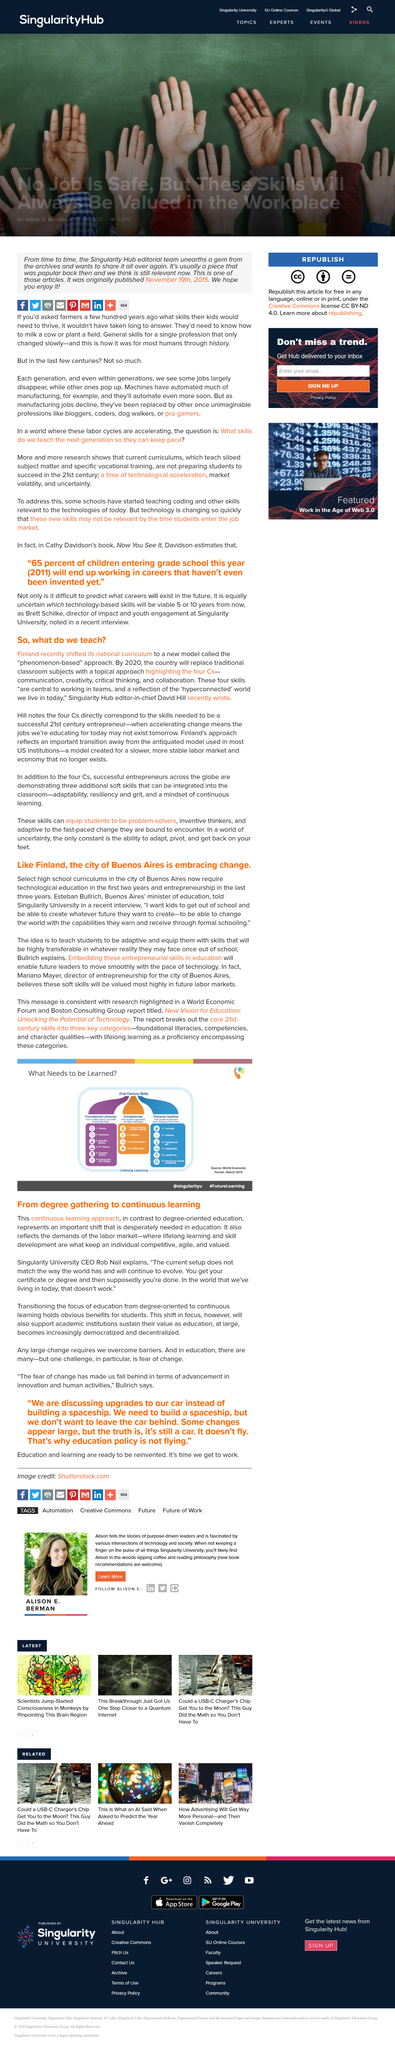Highlight a few significant elements in this photo. Yes, communication, creativity, critical thinking, and collaboration are skills that are essential for success as an entrepreneur in the 21st century. The select high schools in Buenos Aires require two years of technological education. David Hill is the editor-in-chief for Singularity Hub. The report from the World Economic Forum and Boston Consulting Group, titled "New Vision for Education: Unlocking the Potential of Technology", provides a comprehensive overview of the potential of technology in education and outlines a new vision for the future of learning. Esteban Bullrich desires to impart to students the importance of adaptability and equip them with transferable skills that will serve them well in whatever reality they may face after graduation. 